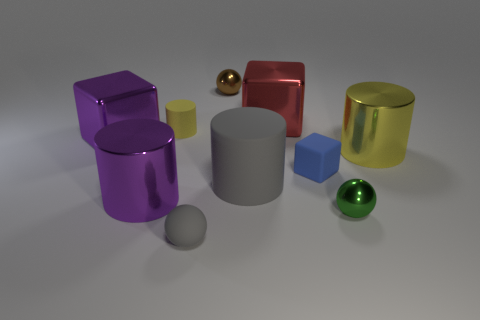Subtract all large shiny blocks. How many blocks are left? 1 Subtract all green spheres. How many spheres are left? 2 Subtract 4 cylinders. How many cylinders are left? 0 Subtract all cubes. How many objects are left? 7 Add 7 large brown balls. How many large brown balls exist? 7 Subtract 0 purple balls. How many objects are left? 10 Subtract all brown balls. Subtract all gray cubes. How many balls are left? 2 Subtract all purple balls. How many green cylinders are left? 0 Subtract all small purple shiny spheres. Subtract all tiny yellow rubber cylinders. How many objects are left? 9 Add 6 small green objects. How many small green objects are left? 7 